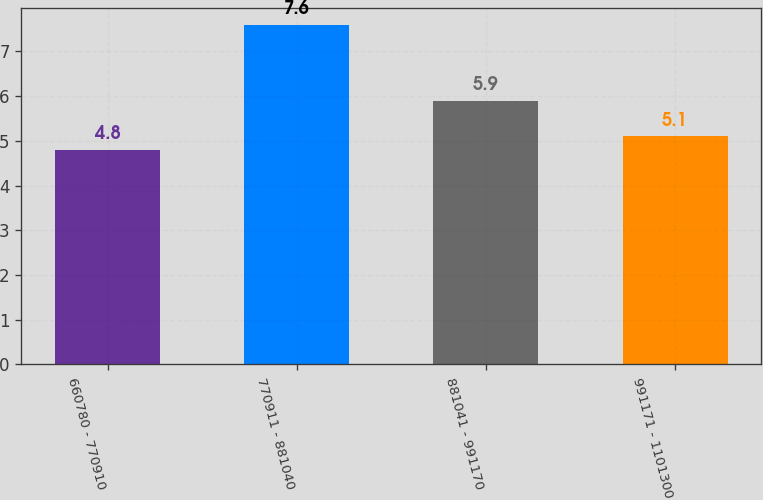<chart> <loc_0><loc_0><loc_500><loc_500><bar_chart><fcel>660780 - 770910<fcel>770911 - 881040<fcel>881041 - 991170<fcel>991171 - 1101300<nl><fcel>4.8<fcel>7.6<fcel>5.9<fcel>5.1<nl></chart> 